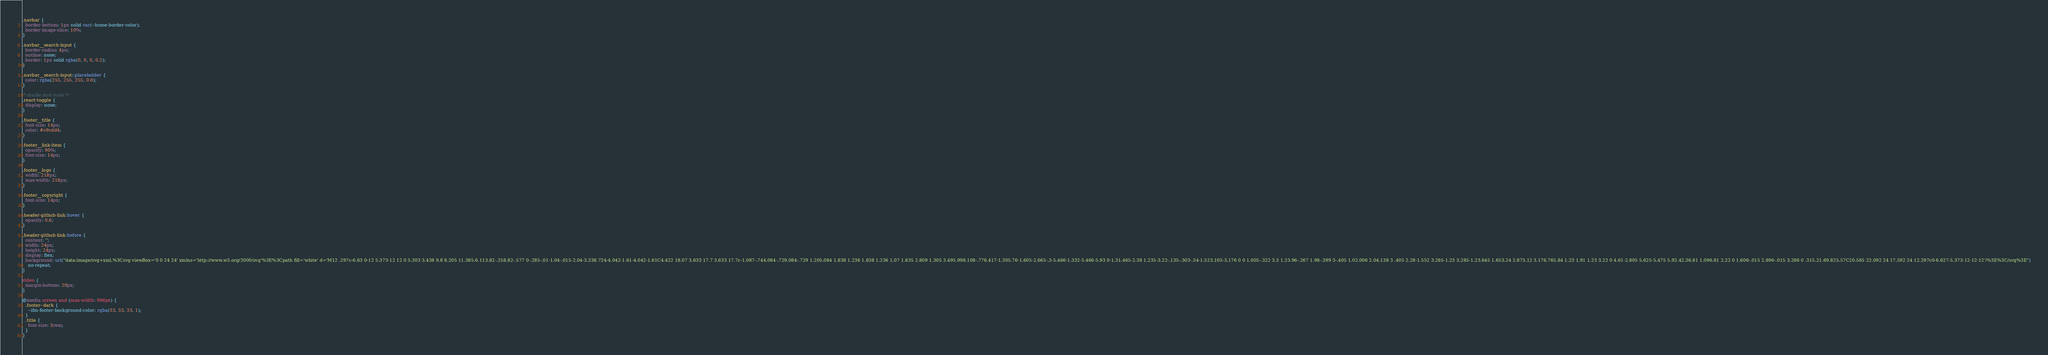Convert code to text. <code><loc_0><loc_0><loc_500><loc_500><_CSS_>
.navbar {
  border-bottom: 1px solid var(--home-border-color);
  border-image-slice: 10%;
}

.navbar__search-input {
  border-radius: 4px;
  outline: none;
  border: 1px solid rgba(0, 0, 0, 0.2);
}

.navbar__search-input::placeholder {
  color: rgba(255, 255, 255, 0.6);
}

/* disable dark mode */
.react-toggle {
  display: none;
}

.footer__title {
  font-size: 14px;
  color: #c9cdd4;
}

.footer__link-item {
  opacity: 90%;
  font-size: 14px;
}

.footer__logo {
  width: 218px;
  max-width: 218px;
}

.footer__copyright {
  font-size: 14px;
}

.header-github-link:hover {
  opacity: 0.6;
}

.header-github-link:before {
  content: '';
  width: 24px;
  height: 24px;
  display: flex;
  background: url("data:image/svg+xml,%3Csvg viewBox='0 0 24 24' xmlns='http://www.w3.org/2000/svg'%3E%3Cpath fill='white' d='M12 .297c-6.63 0-12 5.373-12 12 0 5.303 3.438 9.8 8.205 11.385.6.113.82-.258.82-.577 0-.285-.01-1.04-.015-2.04-3.338.724-4.042-1.61-4.042-1.61C4.422 18.07 3.633 17.7 3.633 17.7c-1.087-.744.084-.729.084-.729 1.205.084 1.838 1.236 1.838 1.236 1.07 1.835 2.809 1.305 3.495.998.108-.776.417-1.305.76-1.605-2.665-.3-5.466-1.332-5.466-5.93 0-1.31.465-2.38 1.235-3.22-.135-.303-.54-1.523.105-3.176 0 0 1.005-.322 3.3 1.23.96-.267 1.98-.399 3-.405 1.02.006 2.04.138 3 .405 2.28-1.552 3.285-1.23 3.285-1.23.645 1.653.24 2.873.12 3.176.765.84 1.23 1.91 1.23 3.22 0 4.61-2.805 5.625-5.475 5.92.42.36.81 1.096.81 2.22 0 1.606-.015 2.896-.015 3.286 0 .315.21.69.825.57C20.565 22.092 24 17.592 24 12.297c0-6.627-5.373-12-12-12'/%3E%3C/svg%3E")
    no-repeat;
}

video {
  margin-bottom: 20px;
}

@media screen and (max-width: 966px) {
  .footer--dark {
    --ifm-footer-background-color: rgba(33, 33, 33, 1);
  }
  .title {
    font-size: 3rem;
  }
}
</code> 